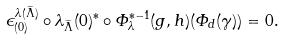<formula> <loc_0><loc_0><loc_500><loc_500>\epsilon _ { ( 0 ) } ^ { \lambda ( \widetilde { \Lambda } ) } \circ \lambda _ { \widetilde { \Lambda } } ( 0 ) ^ { * } \circ \varPhi _ { \lambda } ^ { * - 1 } ( g , h ) ( \varPhi _ { d } ( \gamma ) ) = 0 .</formula> 